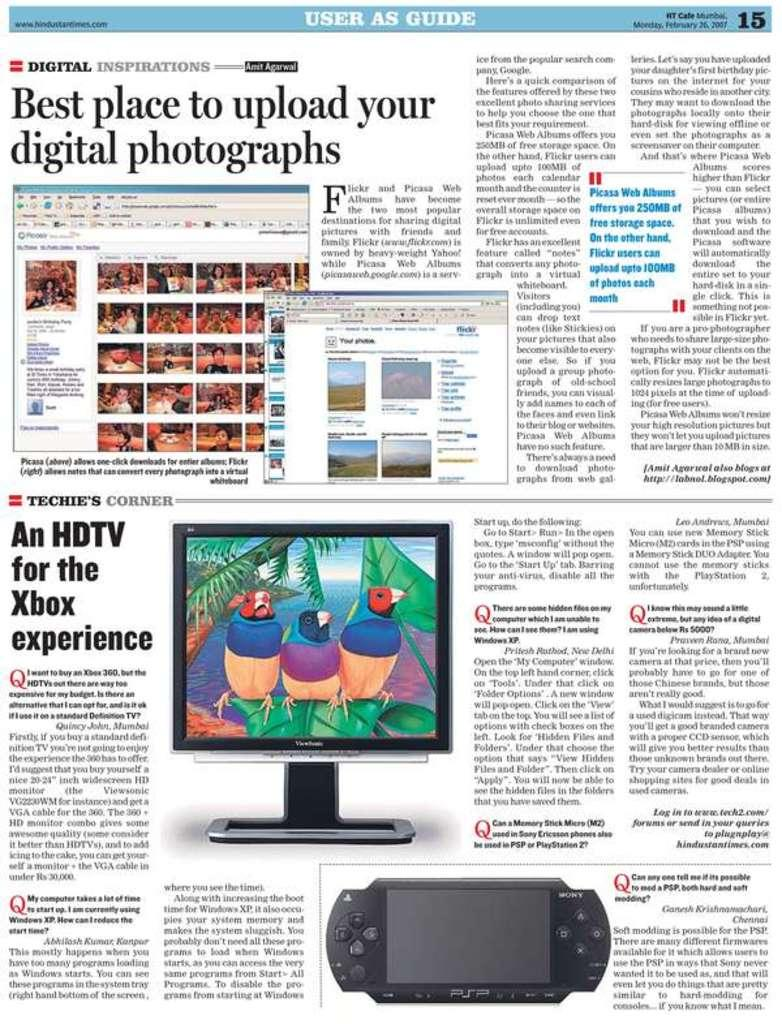<image>
Create a compact narrative representing the image presented. A page of a magazine with information on digital issues. 